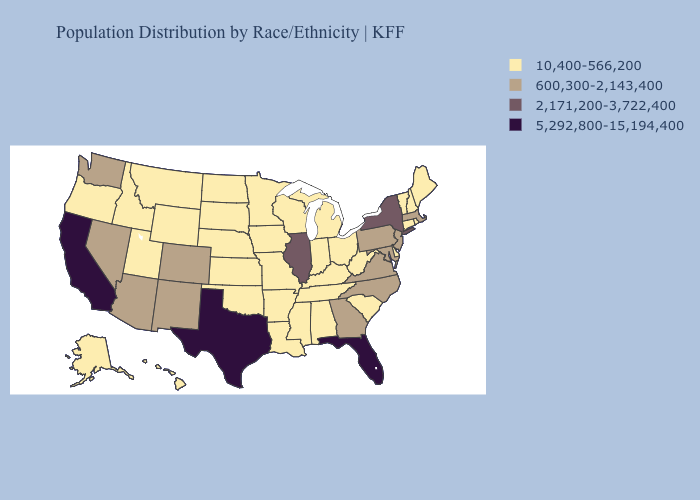Among the states that border Texas , does New Mexico have the lowest value?
Answer briefly. No. What is the lowest value in states that border Rhode Island?
Give a very brief answer. 10,400-566,200. What is the lowest value in states that border West Virginia?
Keep it brief. 10,400-566,200. Does California have the highest value in the West?
Keep it brief. Yes. Does the first symbol in the legend represent the smallest category?
Keep it brief. Yes. What is the highest value in the USA?
Write a very short answer. 5,292,800-15,194,400. Among the states that border Kansas , which have the lowest value?
Write a very short answer. Missouri, Nebraska, Oklahoma. What is the value of New York?
Keep it brief. 2,171,200-3,722,400. Which states hav the highest value in the Northeast?
Answer briefly. New York. What is the value of Vermont?
Be succinct. 10,400-566,200. What is the value of Kentucky?
Concise answer only. 10,400-566,200. What is the value of Oklahoma?
Quick response, please. 10,400-566,200. Which states have the lowest value in the USA?
Give a very brief answer. Alabama, Alaska, Arkansas, Connecticut, Delaware, Hawaii, Idaho, Indiana, Iowa, Kansas, Kentucky, Louisiana, Maine, Michigan, Minnesota, Mississippi, Missouri, Montana, Nebraska, New Hampshire, North Dakota, Ohio, Oklahoma, Oregon, Rhode Island, South Carolina, South Dakota, Tennessee, Utah, Vermont, West Virginia, Wisconsin, Wyoming. Among the states that border Pennsylvania , which have the highest value?
Write a very short answer. New York. Which states have the lowest value in the USA?
Be succinct. Alabama, Alaska, Arkansas, Connecticut, Delaware, Hawaii, Idaho, Indiana, Iowa, Kansas, Kentucky, Louisiana, Maine, Michigan, Minnesota, Mississippi, Missouri, Montana, Nebraska, New Hampshire, North Dakota, Ohio, Oklahoma, Oregon, Rhode Island, South Carolina, South Dakota, Tennessee, Utah, Vermont, West Virginia, Wisconsin, Wyoming. 